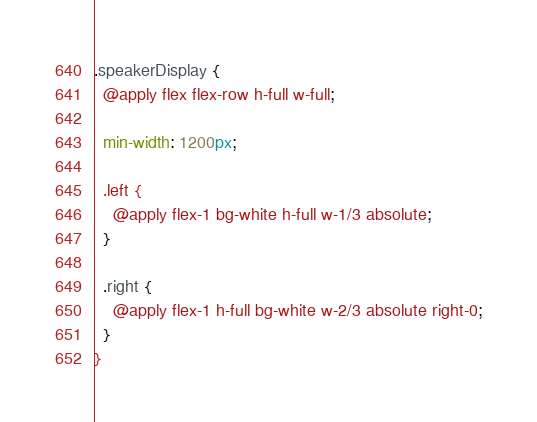<code> <loc_0><loc_0><loc_500><loc_500><_CSS_>.speakerDisplay {
  @apply flex flex-row h-full w-full;

  min-width: 1200px;

  .left {
    @apply flex-1 bg-white h-full w-1/3 absolute;
  }

  .right {
    @apply flex-1 h-full bg-white w-2/3 absolute right-0;
  }
}
</code> 